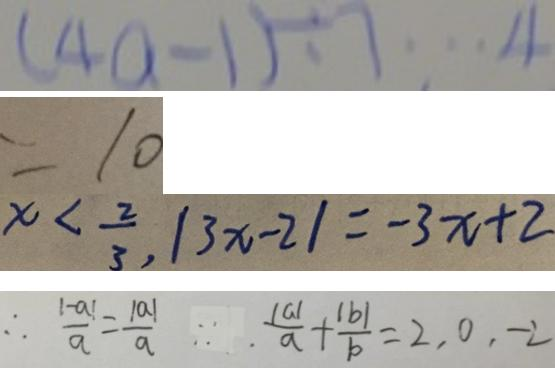Convert formula to latex. <formula><loc_0><loc_0><loc_500><loc_500>( 4 a - 1 ) \div 7 \cdots 4 
 = 1 0 
 x < \frac { 2 } { 3 } , \vert 3 x - 2 \vert = - 3 x + 2 
 \therefore \frac { \vert - a \vert } { a } = \frac { \vert a \vert } { a } . \because . \frac { \vert a \vert } { a } + \frac { \vert b \vert } { b } = 2 , 0 , - 2</formula> 